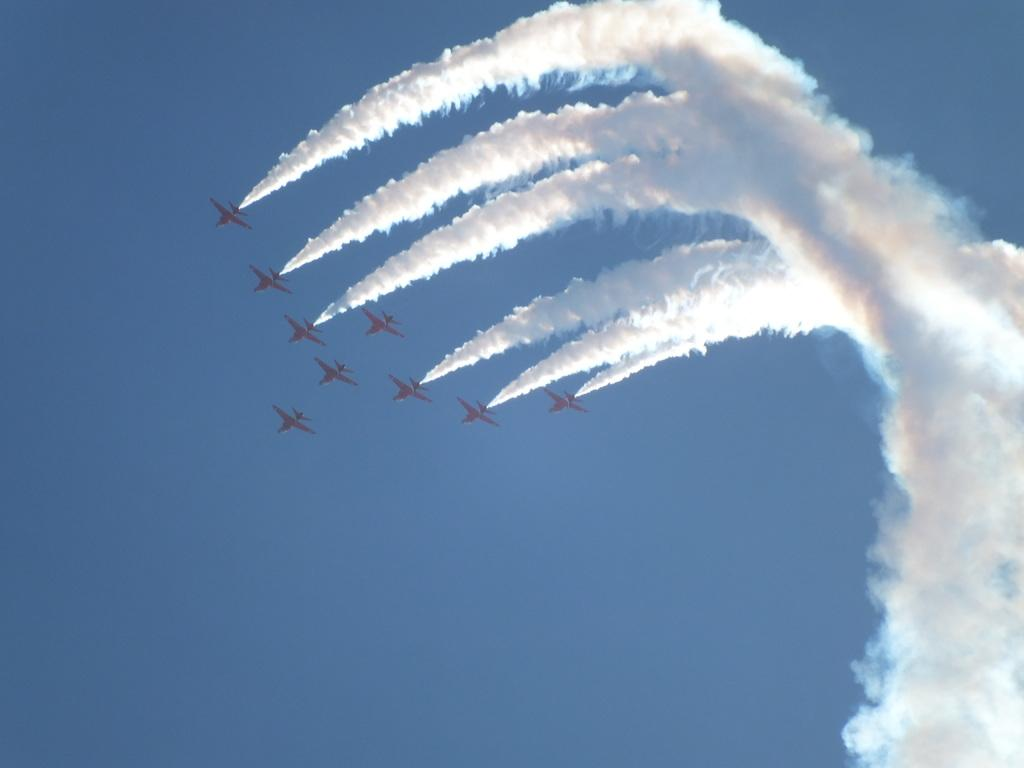What type of vehicles are in the image? There are army jets in the image. What are the jets doing in the image? The jets are flying in the sky. What is the result of the jets flying in the image? The jets are leaving smoke. How many holes can be seen in the image? There are no holes present in the image. What type of roll is being performed by the jets in the image? The jets are not performing any rolls in the image; they are simply flying and leaving smoke. 